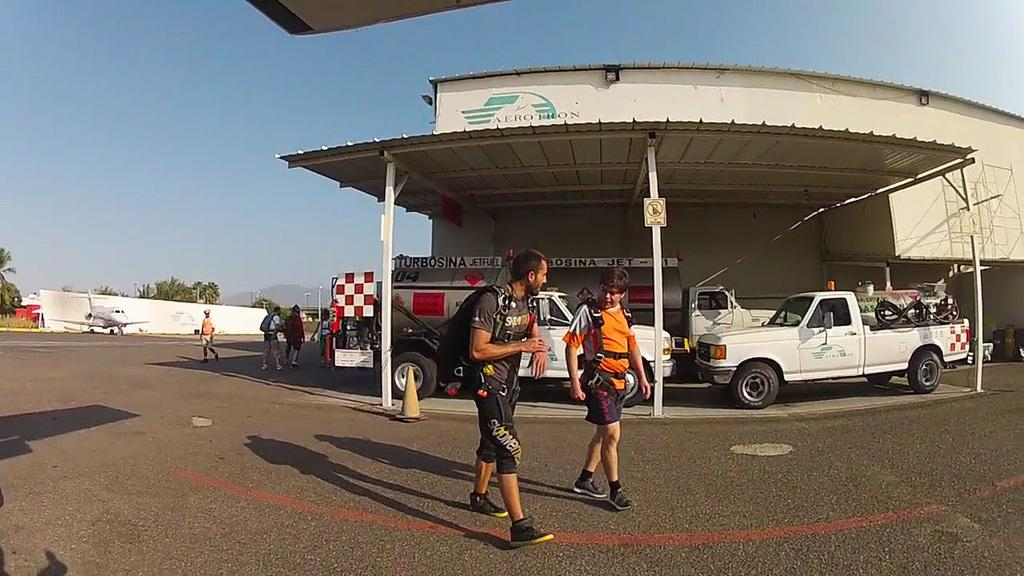What type of structure can be seen in the image? There is a shed in the image. What natural features are present in the image? There are hills and trees in the image. What man-made structures can be seen in the image? There are street poles, street lights, and name boards in the image. What is happening in the sky in the image? There is an airplane in the image. What type of transportation is visible in the image? There are motor vehicles in the image. What type of ground surface is present in the image? There is grass in the image. What activity can be seen involving people in the image? There are persons walking on the road in the image. Can you tell me the denomination of the receipt in the image? There is no receipt present in the image. What religion is being practiced by the persons walking on the road in the image? There is no indication of any religious activity in the image. 